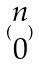Convert formula to latex. <formula><loc_0><loc_0><loc_500><loc_500>( \begin{matrix} n \\ 0 \end{matrix} )</formula> 